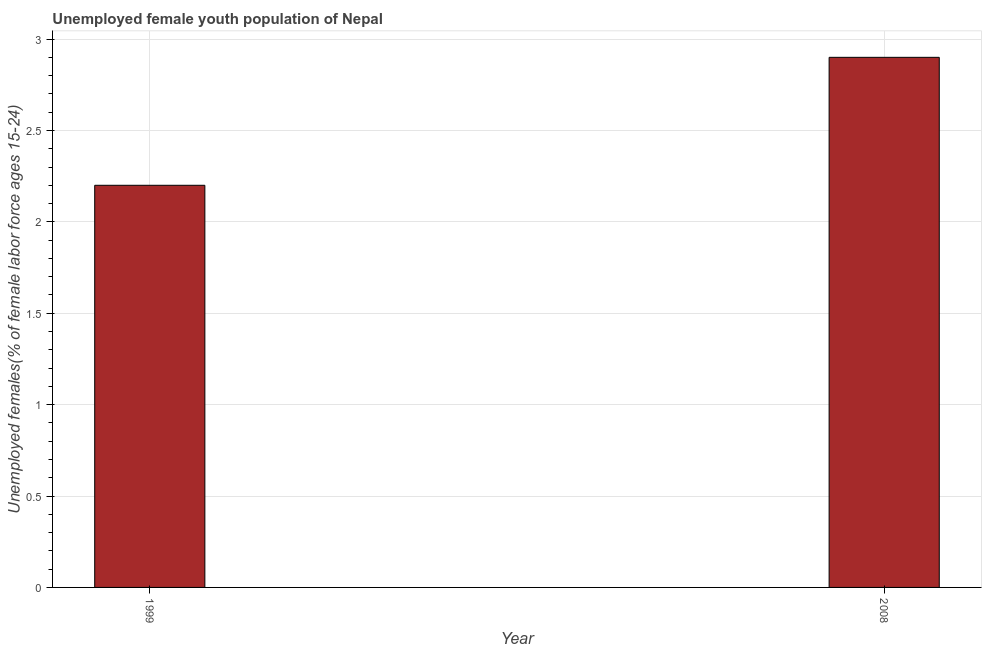Does the graph contain grids?
Keep it short and to the point. Yes. What is the title of the graph?
Make the answer very short. Unemployed female youth population of Nepal. What is the label or title of the X-axis?
Offer a very short reply. Year. What is the label or title of the Y-axis?
Ensure brevity in your answer.  Unemployed females(% of female labor force ages 15-24). What is the unemployed female youth in 2008?
Keep it short and to the point. 2.9. Across all years, what is the maximum unemployed female youth?
Your response must be concise. 2.9. Across all years, what is the minimum unemployed female youth?
Your response must be concise. 2.2. In which year was the unemployed female youth maximum?
Provide a succinct answer. 2008. What is the sum of the unemployed female youth?
Keep it short and to the point. 5.1. What is the difference between the unemployed female youth in 1999 and 2008?
Provide a succinct answer. -0.7. What is the average unemployed female youth per year?
Your response must be concise. 2.55. What is the median unemployed female youth?
Offer a very short reply. 2.55. What is the ratio of the unemployed female youth in 1999 to that in 2008?
Provide a succinct answer. 0.76. Are all the bars in the graph horizontal?
Your response must be concise. No. What is the difference between two consecutive major ticks on the Y-axis?
Keep it short and to the point. 0.5. What is the Unemployed females(% of female labor force ages 15-24) of 1999?
Make the answer very short. 2.2. What is the Unemployed females(% of female labor force ages 15-24) in 2008?
Your response must be concise. 2.9. What is the difference between the Unemployed females(% of female labor force ages 15-24) in 1999 and 2008?
Provide a short and direct response. -0.7. What is the ratio of the Unemployed females(% of female labor force ages 15-24) in 1999 to that in 2008?
Make the answer very short. 0.76. 